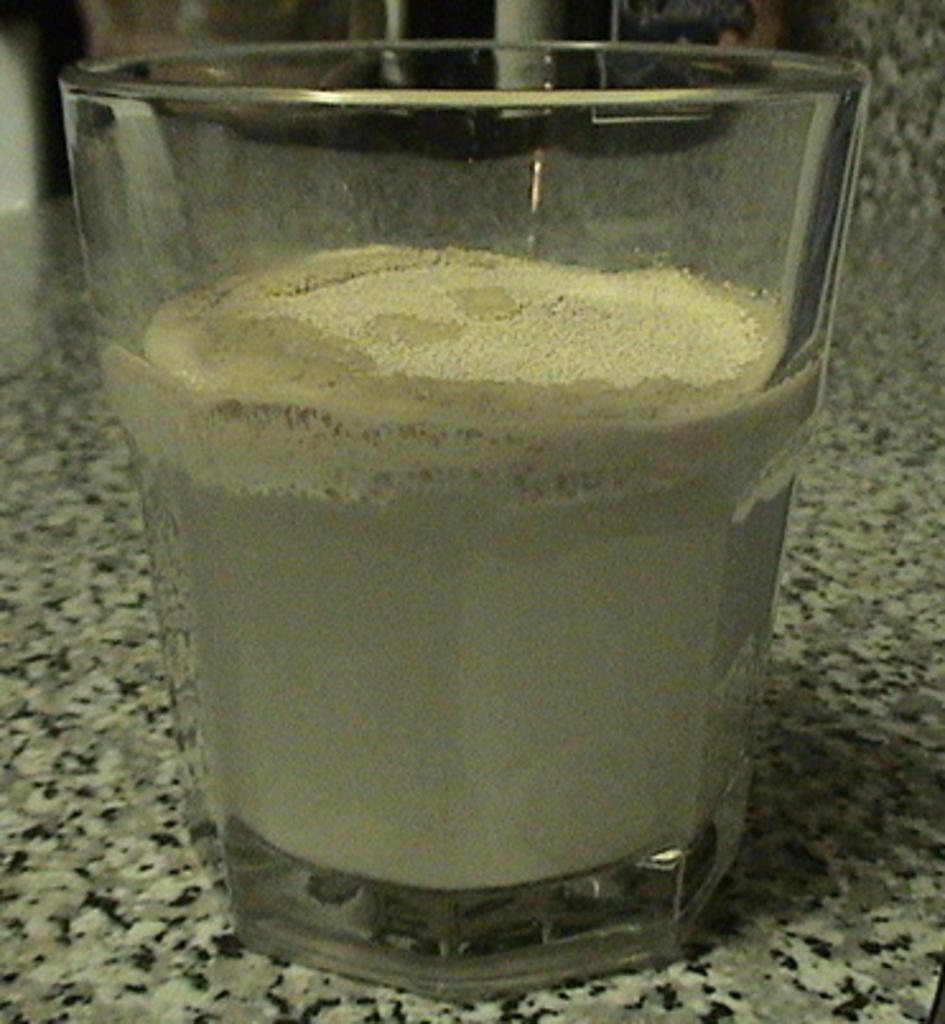Could you give a brief overview of what you see in this image? Here we can see a glass with powder on the platform. 